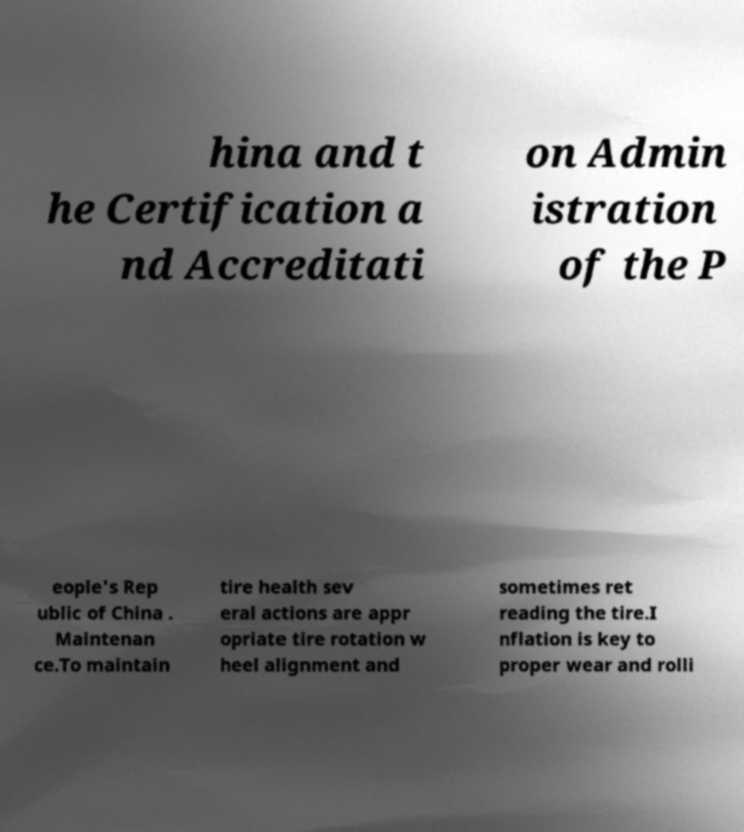I need the written content from this picture converted into text. Can you do that? hina and t he Certification a nd Accreditati on Admin istration of the P eople's Rep ublic of China . Maintenan ce.To maintain tire health sev eral actions are appr opriate tire rotation w heel alignment and sometimes ret reading the tire.I nflation is key to proper wear and rolli 